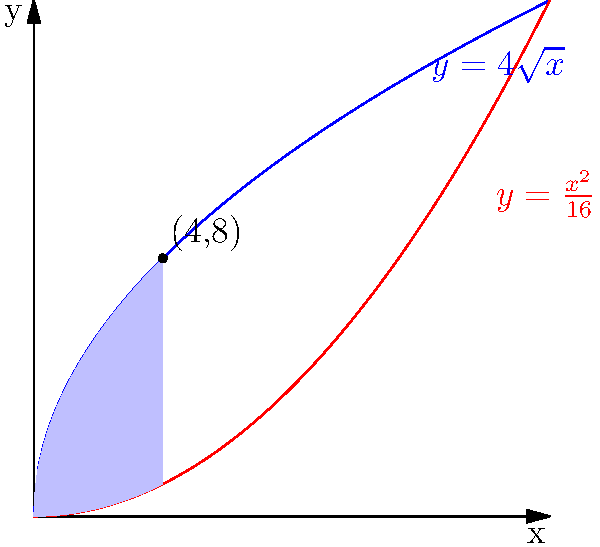In a study of military base layouts, you're analyzing a map where the area between two curves represents the total area covered by different types of facilities. The upper curve is given by $y=4\sqrt{x}$ and the lower curve by $y=\frac{x^2}{16}$. Calculate the total area between these curves. How might this information be useful in understanding the spatial organization of military bases? To find the area between the curves, we need to:

1) Find the points of intersection:
   $4\sqrt{x} = \frac{x^2}{16}$
   $64x = x^4$
   $x^4 - 64x = 0$
   $x(x^3 - 64) = 0$
   $x = 0$ or $x = 4$

2) Set up the integral:
   Area = $\int_{0}^{4} (4\sqrt{x} - \frac{x^2}{16}) dx$

3) Solve the integral:
   $\int_{0}^{4} (4\sqrt{x} - \frac{x^2}{16}) dx$
   $= [4 \cdot \frac{2}{3}x^{3/2} - \frac{1}{48}x^3]_{0}^{4}$
   $= [\frac{8}{3}x^{3/2} - \frac{1}{48}x^3]_{0}^{4}$
   $= (\frac{8}{3} \cdot 8 - \frac{1}{48} \cdot 64) - (0 - 0)$
   $= (\frac{64}{3} - \frac{4}{3}) = 20$

Therefore, the area between the curves is 20 square units.

This information could be useful in understanding the spatial organization of military bases by providing insights into the distribution of different types of facilities within the base. The upper curve might represent the maximum allowable space for certain types of structures, while the lower curve could represent the minimum required space. The area between them shows the flexible space that can be allocated based on specific needs or constraints of the base.
Answer: 20 square units 